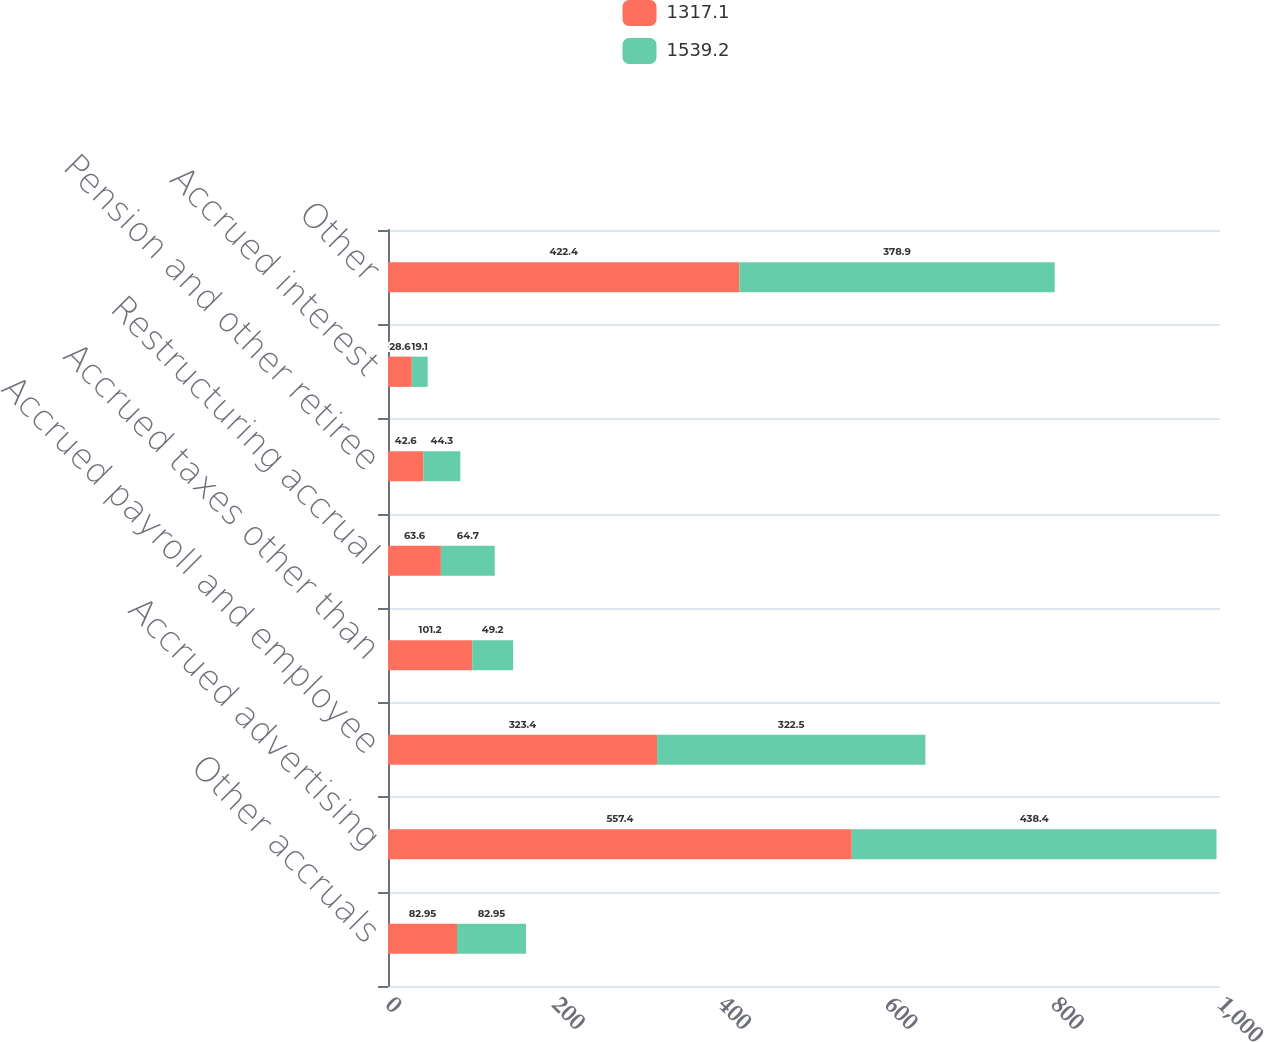Convert chart. <chart><loc_0><loc_0><loc_500><loc_500><stacked_bar_chart><ecel><fcel>Other accruals<fcel>Accrued advertising<fcel>Accrued payroll and employee<fcel>Accrued taxes other than<fcel>Restructuring accrual<fcel>Pension and other retiree<fcel>Accrued interest<fcel>Other<nl><fcel>1317.1<fcel>82.95<fcel>557.4<fcel>323.4<fcel>101.2<fcel>63.6<fcel>42.6<fcel>28.6<fcel>422.4<nl><fcel>1539.2<fcel>82.95<fcel>438.4<fcel>322.5<fcel>49.2<fcel>64.7<fcel>44.3<fcel>19.1<fcel>378.9<nl></chart> 